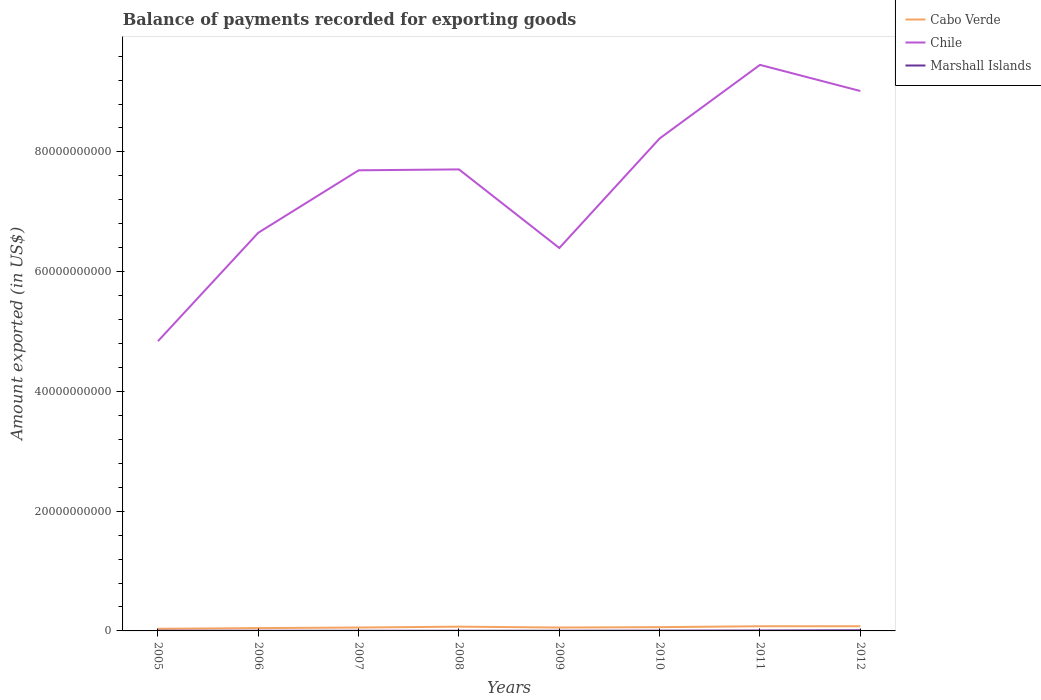How many different coloured lines are there?
Your answer should be very brief. 3. Is the number of lines equal to the number of legend labels?
Make the answer very short. Yes. Across all years, what is the maximum amount exported in Chile?
Keep it short and to the point. 4.84e+1. In which year was the amount exported in Chile maximum?
Make the answer very short. 2005. What is the total amount exported in Chile in the graph?
Offer a very short reply. -1.57e+1. What is the difference between the highest and the second highest amount exported in Marshall Islands?
Your answer should be compact. 8.14e+07. Are the values on the major ticks of Y-axis written in scientific E-notation?
Provide a succinct answer. No. Does the graph contain any zero values?
Offer a very short reply. No. Does the graph contain grids?
Provide a short and direct response. No. Where does the legend appear in the graph?
Ensure brevity in your answer.  Top right. How are the legend labels stacked?
Your answer should be very brief. Vertical. What is the title of the graph?
Make the answer very short. Balance of payments recorded for exporting goods. Does "Low income" appear as one of the legend labels in the graph?
Your answer should be compact. No. What is the label or title of the X-axis?
Ensure brevity in your answer.  Years. What is the label or title of the Y-axis?
Keep it short and to the point. Amount exported (in US$). What is the Amount exported (in US$) in Cabo Verde in 2005?
Offer a terse response. 3.54e+08. What is the Amount exported (in US$) of Chile in 2005?
Your response must be concise. 4.84e+1. What is the Amount exported (in US$) in Marshall Islands in 2005?
Offer a very short reply. 3.33e+07. What is the Amount exported (in US$) in Cabo Verde in 2006?
Provide a short and direct response. 4.72e+08. What is the Amount exported (in US$) of Chile in 2006?
Give a very brief answer. 6.65e+1. What is the Amount exported (in US$) in Marshall Islands in 2006?
Offer a terse response. 2.77e+07. What is the Amount exported (in US$) in Cabo Verde in 2007?
Make the answer very short. 5.66e+08. What is the Amount exported (in US$) of Chile in 2007?
Provide a succinct answer. 7.69e+1. What is the Amount exported (in US$) in Marshall Islands in 2007?
Provide a short and direct response. 2.77e+07. What is the Amount exported (in US$) of Cabo Verde in 2008?
Offer a very short reply. 7.10e+08. What is the Amount exported (in US$) of Chile in 2008?
Provide a succinct answer. 7.71e+1. What is the Amount exported (in US$) of Marshall Islands in 2008?
Make the answer very short. 2.98e+07. What is the Amount exported (in US$) of Cabo Verde in 2009?
Keep it short and to the point. 5.67e+08. What is the Amount exported (in US$) of Chile in 2009?
Your answer should be compact. 6.40e+1. What is the Amount exported (in US$) in Marshall Islands in 2009?
Ensure brevity in your answer.  3.09e+07. What is the Amount exported (in US$) in Cabo Verde in 2010?
Offer a terse response. 6.30e+08. What is the Amount exported (in US$) in Chile in 2010?
Your answer should be compact. 8.23e+1. What is the Amount exported (in US$) of Marshall Islands in 2010?
Your answer should be very brief. 5.00e+07. What is the Amount exported (in US$) in Cabo Verde in 2011?
Provide a succinct answer. 7.82e+08. What is the Amount exported (in US$) in Chile in 2011?
Keep it short and to the point. 9.45e+1. What is the Amount exported (in US$) in Marshall Islands in 2011?
Your answer should be very brief. 7.13e+07. What is the Amount exported (in US$) in Cabo Verde in 2012?
Your answer should be very brief. 7.84e+08. What is the Amount exported (in US$) of Chile in 2012?
Keep it short and to the point. 9.02e+1. What is the Amount exported (in US$) of Marshall Islands in 2012?
Ensure brevity in your answer.  1.09e+08. Across all years, what is the maximum Amount exported (in US$) of Cabo Verde?
Your response must be concise. 7.84e+08. Across all years, what is the maximum Amount exported (in US$) of Chile?
Offer a very short reply. 9.45e+1. Across all years, what is the maximum Amount exported (in US$) of Marshall Islands?
Provide a succinct answer. 1.09e+08. Across all years, what is the minimum Amount exported (in US$) in Cabo Verde?
Keep it short and to the point. 3.54e+08. Across all years, what is the minimum Amount exported (in US$) in Chile?
Your answer should be very brief. 4.84e+1. Across all years, what is the minimum Amount exported (in US$) of Marshall Islands?
Your response must be concise. 2.77e+07. What is the total Amount exported (in US$) of Cabo Verde in the graph?
Provide a short and direct response. 4.87e+09. What is the total Amount exported (in US$) of Chile in the graph?
Your response must be concise. 6.00e+11. What is the total Amount exported (in US$) of Marshall Islands in the graph?
Provide a succinct answer. 3.80e+08. What is the difference between the Amount exported (in US$) in Cabo Verde in 2005 and that in 2006?
Your response must be concise. -1.19e+08. What is the difference between the Amount exported (in US$) in Chile in 2005 and that in 2006?
Ensure brevity in your answer.  -1.81e+1. What is the difference between the Amount exported (in US$) in Marshall Islands in 2005 and that in 2006?
Provide a short and direct response. 5.63e+06. What is the difference between the Amount exported (in US$) of Cabo Verde in 2005 and that in 2007?
Give a very brief answer. -2.12e+08. What is the difference between the Amount exported (in US$) in Chile in 2005 and that in 2007?
Your answer should be very brief. -2.85e+1. What is the difference between the Amount exported (in US$) in Marshall Islands in 2005 and that in 2007?
Keep it short and to the point. 5.56e+06. What is the difference between the Amount exported (in US$) in Cabo Verde in 2005 and that in 2008?
Offer a terse response. -3.57e+08. What is the difference between the Amount exported (in US$) in Chile in 2005 and that in 2008?
Your response must be concise. -2.87e+1. What is the difference between the Amount exported (in US$) of Marshall Islands in 2005 and that in 2008?
Provide a succinct answer. 3.53e+06. What is the difference between the Amount exported (in US$) of Cabo Verde in 2005 and that in 2009?
Ensure brevity in your answer.  -2.14e+08. What is the difference between the Amount exported (in US$) of Chile in 2005 and that in 2009?
Your answer should be compact. -1.56e+1. What is the difference between the Amount exported (in US$) of Marshall Islands in 2005 and that in 2009?
Provide a short and direct response. 2.35e+06. What is the difference between the Amount exported (in US$) in Cabo Verde in 2005 and that in 2010?
Ensure brevity in your answer.  -2.76e+08. What is the difference between the Amount exported (in US$) of Chile in 2005 and that in 2010?
Keep it short and to the point. -3.39e+1. What is the difference between the Amount exported (in US$) of Marshall Islands in 2005 and that in 2010?
Ensure brevity in your answer.  -1.67e+07. What is the difference between the Amount exported (in US$) of Cabo Verde in 2005 and that in 2011?
Offer a terse response. -4.28e+08. What is the difference between the Amount exported (in US$) of Chile in 2005 and that in 2011?
Your answer should be compact. -4.61e+1. What is the difference between the Amount exported (in US$) in Marshall Islands in 2005 and that in 2011?
Ensure brevity in your answer.  -3.80e+07. What is the difference between the Amount exported (in US$) of Cabo Verde in 2005 and that in 2012?
Make the answer very short. -4.30e+08. What is the difference between the Amount exported (in US$) of Chile in 2005 and that in 2012?
Your response must be concise. -4.18e+1. What is the difference between the Amount exported (in US$) in Marshall Islands in 2005 and that in 2012?
Ensure brevity in your answer.  -7.58e+07. What is the difference between the Amount exported (in US$) in Cabo Verde in 2006 and that in 2007?
Your response must be concise. -9.37e+07. What is the difference between the Amount exported (in US$) of Chile in 2006 and that in 2007?
Your answer should be compact. -1.04e+1. What is the difference between the Amount exported (in US$) of Marshall Islands in 2006 and that in 2007?
Provide a succinct answer. -7.31e+04. What is the difference between the Amount exported (in US$) in Cabo Verde in 2006 and that in 2008?
Your answer should be compact. -2.38e+08. What is the difference between the Amount exported (in US$) in Chile in 2006 and that in 2008?
Your response must be concise. -1.06e+1. What is the difference between the Amount exported (in US$) of Marshall Islands in 2006 and that in 2008?
Your answer should be compact. -2.10e+06. What is the difference between the Amount exported (in US$) in Cabo Verde in 2006 and that in 2009?
Make the answer very short. -9.51e+07. What is the difference between the Amount exported (in US$) of Chile in 2006 and that in 2009?
Offer a very short reply. 2.56e+09. What is the difference between the Amount exported (in US$) in Marshall Islands in 2006 and that in 2009?
Keep it short and to the point. -3.28e+06. What is the difference between the Amount exported (in US$) in Cabo Verde in 2006 and that in 2010?
Ensure brevity in your answer.  -1.57e+08. What is the difference between the Amount exported (in US$) of Chile in 2006 and that in 2010?
Ensure brevity in your answer.  -1.57e+1. What is the difference between the Amount exported (in US$) in Marshall Islands in 2006 and that in 2010?
Your answer should be very brief. -2.23e+07. What is the difference between the Amount exported (in US$) of Cabo Verde in 2006 and that in 2011?
Provide a short and direct response. -3.10e+08. What is the difference between the Amount exported (in US$) in Chile in 2006 and that in 2011?
Ensure brevity in your answer.  -2.80e+1. What is the difference between the Amount exported (in US$) in Marshall Islands in 2006 and that in 2011?
Provide a short and direct response. -4.37e+07. What is the difference between the Amount exported (in US$) in Cabo Verde in 2006 and that in 2012?
Keep it short and to the point. -3.12e+08. What is the difference between the Amount exported (in US$) of Chile in 2006 and that in 2012?
Your answer should be very brief. -2.37e+1. What is the difference between the Amount exported (in US$) of Marshall Islands in 2006 and that in 2012?
Make the answer very short. -8.14e+07. What is the difference between the Amount exported (in US$) in Cabo Verde in 2007 and that in 2008?
Provide a succinct answer. -1.44e+08. What is the difference between the Amount exported (in US$) in Chile in 2007 and that in 2008?
Keep it short and to the point. -1.48e+08. What is the difference between the Amount exported (in US$) in Marshall Islands in 2007 and that in 2008?
Your response must be concise. -2.03e+06. What is the difference between the Amount exported (in US$) of Cabo Verde in 2007 and that in 2009?
Keep it short and to the point. -1.34e+06. What is the difference between the Amount exported (in US$) of Chile in 2007 and that in 2009?
Provide a succinct answer. 1.30e+1. What is the difference between the Amount exported (in US$) of Marshall Islands in 2007 and that in 2009?
Make the answer very short. -3.20e+06. What is the difference between the Amount exported (in US$) in Cabo Verde in 2007 and that in 2010?
Ensure brevity in your answer.  -6.37e+07. What is the difference between the Amount exported (in US$) of Chile in 2007 and that in 2010?
Offer a very short reply. -5.32e+09. What is the difference between the Amount exported (in US$) in Marshall Islands in 2007 and that in 2010?
Your answer should be compact. -2.23e+07. What is the difference between the Amount exported (in US$) in Cabo Verde in 2007 and that in 2011?
Your answer should be very brief. -2.16e+08. What is the difference between the Amount exported (in US$) of Chile in 2007 and that in 2011?
Provide a short and direct response. -1.76e+1. What is the difference between the Amount exported (in US$) of Marshall Islands in 2007 and that in 2011?
Keep it short and to the point. -4.36e+07. What is the difference between the Amount exported (in US$) of Cabo Verde in 2007 and that in 2012?
Make the answer very short. -2.18e+08. What is the difference between the Amount exported (in US$) of Chile in 2007 and that in 2012?
Provide a short and direct response. -1.32e+1. What is the difference between the Amount exported (in US$) in Marshall Islands in 2007 and that in 2012?
Your response must be concise. -8.14e+07. What is the difference between the Amount exported (in US$) in Cabo Verde in 2008 and that in 2009?
Your answer should be very brief. 1.43e+08. What is the difference between the Amount exported (in US$) of Chile in 2008 and that in 2009?
Your response must be concise. 1.31e+1. What is the difference between the Amount exported (in US$) of Marshall Islands in 2008 and that in 2009?
Keep it short and to the point. -1.17e+06. What is the difference between the Amount exported (in US$) in Cabo Verde in 2008 and that in 2010?
Offer a terse response. 8.07e+07. What is the difference between the Amount exported (in US$) of Chile in 2008 and that in 2010?
Your answer should be compact. -5.17e+09. What is the difference between the Amount exported (in US$) of Marshall Islands in 2008 and that in 2010?
Provide a short and direct response. -2.02e+07. What is the difference between the Amount exported (in US$) in Cabo Verde in 2008 and that in 2011?
Offer a very short reply. -7.14e+07. What is the difference between the Amount exported (in US$) of Chile in 2008 and that in 2011?
Provide a short and direct response. -1.75e+1. What is the difference between the Amount exported (in US$) in Marshall Islands in 2008 and that in 2011?
Keep it short and to the point. -4.16e+07. What is the difference between the Amount exported (in US$) in Cabo Verde in 2008 and that in 2012?
Offer a very short reply. -7.34e+07. What is the difference between the Amount exported (in US$) of Chile in 2008 and that in 2012?
Offer a very short reply. -1.31e+1. What is the difference between the Amount exported (in US$) in Marshall Islands in 2008 and that in 2012?
Provide a short and direct response. -7.93e+07. What is the difference between the Amount exported (in US$) of Cabo Verde in 2009 and that in 2010?
Your response must be concise. -6.24e+07. What is the difference between the Amount exported (in US$) of Chile in 2009 and that in 2010?
Provide a succinct answer. -1.83e+1. What is the difference between the Amount exported (in US$) of Marshall Islands in 2009 and that in 2010?
Your answer should be very brief. -1.91e+07. What is the difference between the Amount exported (in US$) of Cabo Verde in 2009 and that in 2011?
Make the answer very short. -2.15e+08. What is the difference between the Amount exported (in US$) of Chile in 2009 and that in 2011?
Your response must be concise. -3.06e+1. What is the difference between the Amount exported (in US$) of Marshall Islands in 2009 and that in 2011?
Keep it short and to the point. -4.04e+07. What is the difference between the Amount exported (in US$) in Cabo Verde in 2009 and that in 2012?
Ensure brevity in your answer.  -2.17e+08. What is the difference between the Amount exported (in US$) of Chile in 2009 and that in 2012?
Provide a succinct answer. -2.62e+1. What is the difference between the Amount exported (in US$) of Marshall Islands in 2009 and that in 2012?
Ensure brevity in your answer.  -7.82e+07. What is the difference between the Amount exported (in US$) in Cabo Verde in 2010 and that in 2011?
Give a very brief answer. -1.52e+08. What is the difference between the Amount exported (in US$) in Chile in 2010 and that in 2011?
Make the answer very short. -1.23e+1. What is the difference between the Amount exported (in US$) of Marshall Islands in 2010 and that in 2011?
Offer a very short reply. -2.13e+07. What is the difference between the Amount exported (in US$) in Cabo Verde in 2010 and that in 2012?
Make the answer very short. -1.54e+08. What is the difference between the Amount exported (in US$) of Chile in 2010 and that in 2012?
Make the answer very short. -7.92e+09. What is the difference between the Amount exported (in US$) of Marshall Islands in 2010 and that in 2012?
Provide a short and direct response. -5.91e+07. What is the difference between the Amount exported (in US$) of Cabo Verde in 2011 and that in 2012?
Your response must be concise. -2.00e+06. What is the difference between the Amount exported (in US$) in Chile in 2011 and that in 2012?
Ensure brevity in your answer.  4.37e+09. What is the difference between the Amount exported (in US$) in Marshall Islands in 2011 and that in 2012?
Make the answer very short. -3.78e+07. What is the difference between the Amount exported (in US$) in Cabo Verde in 2005 and the Amount exported (in US$) in Chile in 2006?
Provide a short and direct response. -6.62e+1. What is the difference between the Amount exported (in US$) in Cabo Verde in 2005 and the Amount exported (in US$) in Marshall Islands in 2006?
Offer a very short reply. 3.26e+08. What is the difference between the Amount exported (in US$) of Chile in 2005 and the Amount exported (in US$) of Marshall Islands in 2006?
Your response must be concise. 4.84e+1. What is the difference between the Amount exported (in US$) of Cabo Verde in 2005 and the Amount exported (in US$) of Chile in 2007?
Ensure brevity in your answer.  -7.66e+1. What is the difference between the Amount exported (in US$) of Cabo Verde in 2005 and the Amount exported (in US$) of Marshall Islands in 2007?
Provide a succinct answer. 3.26e+08. What is the difference between the Amount exported (in US$) of Chile in 2005 and the Amount exported (in US$) of Marshall Islands in 2007?
Keep it short and to the point. 4.84e+1. What is the difference between the Amount exported (in US$) of Cabo Verde in 2005 and the Amount exported (in US$) of Chile in 2008?
Keep it short and to the point. -7.67e+1. What is the difference between the Amount exported (in US$) of Cabo Verde in 2005 and the Amount exported (in US$) of Marshall Islands in 2008?
Provide a succinct answer. 3.24e+08. What is the difference between the Amount exported (in US$) of Chile in 2005 and the Amount exported (in US$) of Marshall Islands in 2008?
Ensure brevity in your answer.  4.84e+1. What is the difference between the Amount exported (in US$) in Cabo Verde in 2005 and the Amount exported (in US$) in Chile in 2009?
Give a very brief answer. -6.36e+1. What is the difference between the Amount exported (in US$) in Cabo Verde in 2005 and the Amount exported (in US$) in Marshall Islands in 2009?
Provide a succinct answer. 3.23e+08. What is the difference between the Amount exported (in US$) in Chile in 2005 and the Amount exported (in US$) in Marshall Islands in 2009?
Give a very brief answer. 4.84e+1. What is the difference between the Amount exported (in US$) of Cabo Verde in 2005 and the Amount exported (in US$) of Chile in 2010?
Keep it short and to the point. -8.19e+1. What is the difference between the Amount exported (in US$) of Cabo Verde in 2005 and the Amount exported (in US$) of Marshall Islands in 2010?
Offer a terse response. 3.04e+08. What is the difference between the Amount exported (in US$) in Chile in 2005 and the Amount exported (in US$) in Marshall Islands in 2010?
Offer a very short reply. 4.84e+1. What is the difference between the Amount exported (in US$) of Cabo Verde in 2005 and the Amount exported (in US$) of Chile in 2011?
Provide a short and direct response. -9.42e+1. What is the difference between the Amount exported (in US$) of Cabo Verde in 2005 and the Amount exported (in US$) of Marshall Islands in 2011?
Keep it short and to the point. 2.82e+08. What is the difference between the Amount exported (in US$) of Chile in 2005 and the Amount exported (in US$) of Marshall Islands in 2011?
Your answer should be compact. 4.83e+1. What is the difference between the Amount exported (in US$) in Cabo Verde in 2005 and the Amount exported (in US$) in Chile in 2012?
Ensure brevity in your answer.  -8.98e+1. What is the difference between the Amount exported (in US$) in Cabo Verde in 2005 and the Amount exported (in US$) in Marshall Islands in 2012?
Your answer should be very brief. 2.45e+08. What is the difference between the Amount exported (in US$) of Chile in 2005 and the Amount exported (in US$) of Marshall Islands in 2012?
Ensure brevity in your answer.  4.83e+1. What is the difference between the Amount exported (in US$) of Cabo Verde in 2006 and the Amount exported (in US$) of Chile in 2007?
Ensure brevity in your answer.  -7.65e+1. What is the difference between the Amount exported (in US$) of Cabo Verde in 2006 and the Amount exported (in US$) of Marshall Islands in 2007?
Provide a short and direct response. 4.45e+08. What is the difference between the Amount exported (in US$) of Chile in 2006 and the Amount exported (in US$) of Marshall Islands in 2007?
Your answer should be very brief. 6.65e+1. What is the difference between the Amount exported (in US$) of Cabo Verde in 2006 and the Amount exported (in US$) of Chile in 2008?
Offer a terse response. -7.66e+1. What is the difference between the Amount exported (in US$) in Cabo Verde in 2006 and the Amount exported (in US$) in Marshall Islands in 2008?
Make the answer very short. 4.43e+08. What is the difference between the Amount exported (in US$) of Chile in 2006 and the Amount exported (in US$) of Marshall Islands in 2008?
Provide a short and direct response. 6.65e+1. What is the difference between the Amount exported (in US$) in Cabo Verde in 2006 and the Amount exported (in US$) in Chile in 2009?
Ensure brevity in your answer.  -6.35e+1. What is the difference between the Amount exported (in US$) in Cabo Verde in 2006 and the Amount exported (in US$) in Marshall Islands in 2009?
Provide a short and direct response. 4.41e+08. What is the difference between the Amount exported (in US$) of Chile in 2006 and the Amount exported (in US$) of Marshall Islands in 2009?
Ensure brevity in your answer.  6.65e+1. What is the difference between the Amount exported (in US$) in Cabo Verde in 2006 and the Amount exported (in US$) in Chile in 2010?
Provide a short and direct response. -8.18e+1. What is the difference between the Amount exported (in US$) of Cabo Verde in 2006 and the Amount exported (in US$) of Marshall Islands in 2010?
Keep it short and to the point. 4.22e+08. What is the difference between the Amount exported (in US$) in Chile in 2006 and the Amount exported (in US$) in Marshall Islands in 2010?
Offer a terse response. 6.65e+1. What is the difference between the Amount exported (in US$) of Cabo Verde in 2006 and the Amount exported (in US$) of Chile in 2011?
Offer a very short reply. -9.41e+1. What is the difference between the Amount exported (in US$) of Cabo Verde in 2006 and the Amount exported (in US$) of Marshall Islands in 2011?
Provide a succinct answer. 4.01e+08. What is the difference between the Amount exported (in US$) of Chile in 2006 and the Amount exported (in US$) of Marshall Islands in 2011?
Your answer should be very brief. 6.64e+1. What is the difference between the Amount exported (in US$) in Cabo Verde in 2006 and the Amount exported (in US$) in Chile in 2012?
Provide a short and direct response. -8.97e+1. What is the difference between the Amount exported (in US$) of Cabo Verde in 2006 and the Amount exported (in US$) of Marshall Islands in 2012?
Provide a succinct answer. 3.63e+08. What is the difference between the Amount exported (in US$) of Chile in 2006 and the Amount exported (in US$) of Marshall Islands in 2012?
Offer a terse response. 6.64e+1. What is the difference between the Amount exported (in US$) of Cabo Verde in 2007 and the Amount exported (in US$) of Chile in 2008?
Offer a terse response. -7.65e+1. What is the difference between the Amount exported (in US$) in Cabo Verde in 2007 and the Amount exported (in US$) in Marshall Islands in 2008?
Offer a very short reply. 5.36e+08. What is the difference between the Amount exported (in US$) in Chile in 2007 and the Amount exported (in US$) in Marshall Islands in 2008?
Give a very brief answer. 7.69e+1. What is the difference between the Amount exported (in US$) in Cabo Verde in 2007 and the Amount exported (in US$) in Chile in 2009?
Make the answer very short. -6.34e+1. What is the difference between the Amount exported (in US$) of Cabo Verde in 2007 and the Amount exported (in US$) of Marshall Islands in 2009?
Give a very brief answer. 5.35e+08. What is the difference between the Amount exported (in US$) of Chile in 2007 and the Amount exported (in US$) of Marshall Islands in 2009?
Offer a very short reply. 7.69e+1. What is the difference between the Amount exported (in US$) in Cabo Verde in 2007 and the Amount exported (in US$) in Chile in 2010?
Keep it short and to the point. -8.17e+1. What is the difference between the Amount exported (in US$) of Cabo Verde in 2007 and the Amount exported (in US$) of Marshall Islands in 2010?
Ensure brevity in your answer.  5.16e+08. What is the difference between the Amount exported (in US$) in Chile in 2007 and the Amount exported (in US$) in Marshall Islands in 2010?
Your answer should be very brief. 7.69e+1. What is the difference between the Amount exported (in US$) of Cabo Verde in 2007 and the Amount exported (in US$) of Chile in 2011?
Provide a short and direct response. -9.40e+1. What is the difference between the Amount exported (in US$) in Cabo Verde in 2007 and the Amount exported (in US$) in Marshall Islands in 2011?
Your answer should be compact. 4.95e+08. What is the difference between the Amount exported (in US$) of Chile in 2007 and the Amount exported (in US$) of Marshall Islands in 2011?
Your answer should be very brief. 7.69e+1. What is the difference between the Amount exported (in US$) in Cabo Verde in 2007 and the Amount exported (in US$) in Chile in 2012?
Provide a succinct answer. -8.96e+1. What is the difference between the Amount exported (in US$) of Cabo Verde in 2007 and the Amount exported (in US$) of Marshall Islands in 2012?
Your response must be concise. 4.57e+08. What is the difference between the Amount exported (in US$) of Chile in 2007 and the Amount exported (in US$) of Marshall Islands in 2012?
Provide a short and direct response. 7.68e+1. What is the difference between the Amount exported (in US$) in Cabo Verde in 2008 and the Amount exported (in US$) in Chile in 2009?
Offer a terse response. -6.32e+1. What is the difference between the Amount exported (in US$) of Cabo Verde in 2008 and the Amount exported (in US$) of Marshall Islands in 2009?
Make the answer very short. 6.80e+08. What is the difference between the Amount exported (in US$) in Chile in 2008 and the Amount exported (in US$) in Marshall Islands in 2009?
Your answer should be very brief. 7.71e+1. What is the difference between the Amount exported (in US$) in Cabo Verde in 2008 and the Amount exported (in US$) in Chile in 2010?
Give a very brief answer. -8.15e+1. What is the difference between the Amount exported (in US$) in Cabo Verde in 2008 and the Amount exported (in US$) in Marshall Islands in 2010?
Provide a short and direct response. 6.61e+08. What is the difference between the Amount exported (in US$) in Chile in 2008 and the Amount exported (in US$) in Marshall Islands in 2010?
Provide a short and direct response. 7.70e+1. What is the difference between the Amount exported (in US$) in Cabo Verde in 2008 and the Amount exported (in US$) in Chile in 2011?
Make the answer very short. -9.38e+1. What is the difference between the Amount exported (in US$) of Cabo Verde in 2008 and the Amount exported (in US$) of Marshall Islands in 2011?
Offer a very short reply. 6.39e+08. What is the difference between the Amount exported (in US$) in Chile in 2008 and the Amount exported (in US$) in Marshall Islands in 2011?
Ensure brevity in your answer.  7.70e+1. What is the difference between the Amount exported (in US$) in Cabo Verde in 2008 and the Amount exported (in US$) in Chile in 2012?
Ensure brevity in your answer.  -8.95e+1. What is the difference between the Amount exported (in US$) in Cabo Verde in 2008 and the Amount exported (in US$) in Marshall Islands in 2012?
Offer a very short reply. 6.01e+08. What is the difference between the Amount exported (in US$) in Chile in 2008 and the Amount exported (in US$) in Marshall Islands in 2012?
Provide a succinct answer. 7.70e+1. What is the difference between the Amount exported (in US$) of Cabo Verde in 2009 and the Amount exported (in US$) of Chile in 2010?
Provide a succinct answer. -8.17e+1. What is the difference between the Amount exported (in US$) of Cabo Verde in 2009 and the Amount exported (in US$) of Marshall Islands in 2010?
Give a very brief answer. 5.17e+08. What is the difference between the Amount exported (in US$) in Chile in 2009 and the Amount exported (in US$) in Marshall Islands in 2010?
Offer a very short reply. 6.39e+1. What is the difference between the Amount exported (in US$) of Cabo Verde in 2009 and the Amount exported (in US$) of Chile in 2011?
Provide a succinct answer. -9.40e+1. What is the difference between the Amount exported (in US$) of Cabo Verde in 2009 and the Amount exported (in US$) of Marshall Islands in 2011?
Offer a very short reply. 4.96e+08. What is the difference between the Amount exported (in US$) of Chile in 2009 and the Amount exported (in US$) of Marshall Islands in 2011?
Give a very brief answer. 6.39e+1. What is the difference between the Amount exported (in US$) in Cabo Verde in 2009 and the Amount exported (in US$) in Chile in 2012?
Keep it short and to the point. -8.96e+1. What is the difference between the Amount exported (in US$) in Cabo Verde in 2009 and the Amount exported (in US$) in Marshall Islands in 2012?
Your answer should be compact. 4.58e+08. What is the difference between the Amount exported (in US$) in Chile in 2009 and the Amount exported (in US$) in Marshall Islands in 2012?
Your answer should be compact. 6.38e+1. What is the difference between the Amount exported (in US$) of Cabo Verde in 2010 and the Amount exported (in US$) of Chile in 2011?
Give a very brief answer. -9.39e+1. What is the difference between the Amount exported (in US$) in Cabo Verde in 2010 and the Amount exported (in US$) in Marshall Islands in 2011?
Offer a very short reply. 5.58e+08. What is the difference between the Amount exported (in US$) in Chile in 2010 and the Amount exported (in US$) in Marshall Islands in 2011?
Provide a succinct answer. 8.22e+1. What is the difference between the Amount exported (in US$) of Cabo Verde in 2010 and the Amount exported (in US$) of Chile in 2012?
Offer a very short reply. -8.95e+1. What is the difference between the Amount exported (in US$) in Cabo Verde in 2010 and the Amount exported (in US$) in Marshall Islands in 2012?
Your answer should be compact. 5.21e+08. What is the difference between the Amount exported (in US$) in Chile in 2010 and the Amount exported (in US$) in Marshall Islands in 2012?
Keep it short and to the point. 8.21e+1. What is the difference between the Amount exported (in US$) in Cabo Verde in 2011 and the Amount exported (in US$) in Chile in 2012?
Ensure brevity in your answer.  -8.94e+1. What is the difference between the Amount exported (in US$) of Cabo Verde in 2011 and the Amount exported (in US$) of Marshall Islands in 2012?
Keep it short and to the point. 6.73e+08. What is the difference between the Amount exported (in US$) of Chile in 2011 and the Amount exported (in US$) of Marshall Islands in 2012?
Provide a succinct answer. 9.44e+1. What is the average Amount exported (in US$) of Cabo Verde per year?
Keep it short and to the point. 6.08e+08. What is the average Amount exported (in US$) in Chile per year?
Make the answer very short. 7.50e+1. What is the average Amount exported (in US$) in Marshall Islands per year?
Keep it short and to the point. 4.75e+07. In the year 2005, what is the difference between the Amount exported (in US$) of Cabo Verde and Amount exported (in US$) of Chile?
Provide a succinct answer. -4.80e+1. In the year 2005, what is the difference between the Amount exported (in US$) in Cabo Verde and Amount exported (in US$) in Marshall Islands?
Make the answer very short. 3.20e+08. In the year 2005, what is the difference between the Amount exported (in US$) of Chile and Amount exported (in US$) of Marshall Islands?
Make the answer very short. 4.84e+1. In the year 2006, what is the difference between the Amount exported (in US$) in Cabo Verde and Amount exported (in US$) in Chile?
Keep it short and to the point. -6.60e+1. In the year 2006, what is the difference between the Amount exported (in US$) in Cabo Verde and Amount exported (in US$) in Marshall Islands?
Your response must be concise. 4.45e+08. In the year 2006, what is the difference between the Amount exported (in US$) of Chile and Amount exported (in US$) of Marshall Islands?
Provide a succinct answer. 6.65e+1. In the year 2007, what is the difference between the Amount exported (in US$) of Cabo Verde and Amount exported (in US$) of Chile?
Offer a terse response. -7.64e+1. In the year 2007, what is the difference between the Amount exported (in US$) in Cabo Verde and Amount exported (in US$) in Marshall Islands?
Keep it short and to the point. 5.38e+08. In the year 2007, what is the difference between the Amount exported (in US$) of Chile and Amount exported (in US$) of Marshall Islands?
Offer a very short reply. 7.69e+1. In the year 2008, what is the difference between the Amount exported (in US$) of Cabo Verde and Amount exported (in US$) of Chile?
Keep it short and to the point. -7.64e+1. In the year 2008, what is the difference between the Amount exported (in US$) in Cabo Verde and Amount exported (in US$) in Marshall Islands?
Ensure brevity in your answer.  6.81e+08. In the year 2008, what is the difference between the Amount exported (in US$) in Chile and Amount exported (in US$) in Marshall Islands?
Offer a terse response. 7.71e+1. In the year 2009, what is the difference between the Amount exported (in US$) in Cabo Verde and Amount exported (in US$) in Chile?
Offer a terse response. -6.34e+1. In the year 2009, what is the difference between the Amount exported (in US$) in Cabo Verde and Amount exported (in US$) in Marshall Islands?
Your answer should be very brief. 5.36e+08. In the year 2009, what is the difference between the Amount exported (in US$) of Chile and Amount exported (in US$) of Marshall Islands?
Your answer should be compact. 6.39e+1. In the year 2010, what is the difference between the Amount exported (in US$) in Cabo Verde and Amount exported (in US$) in Chile?
Ensure brevity in your answer.  -8.16e+1. In the year 2010, what is the difference between the Amount exported (in US$) in Cabo Verde and Amount exported (in US$) in Marshall Islands?
Keep it short and to the point. 5.80e+08. In the year 2010, what is the difference between the Amount exported (in US$) of Chile and Amount exported (in US$) of Marshall Islands?
Provide a short and direct response. 8.22e+1. In the year 2011, what is the difference between the Amount exported (in US$) in Cabo Verde and Amount exported (in US$) in Chile?
Keep it short and to the point. -9.38e+1. In the year 2011, what is the difference between the Amount exported (in US$) in Cabo Verde and Amount exported (in US$) in Marshall Islands?
Ensure brevity in your answer.  7.11e+08. In the year 2011, what is the difference between the Amount exported (in US$) of Chile and Amount exported (in US$) of Marshall Islands?
Offer a terse response. 9.45e+1. In the year 2012, what is the difference between the Amount exported (in US$) in Cabo Verde and Amount exported (in US$) in Chile?
Offer a very short reply. -8.94e+1. In the year 2012, what is the difference between the Amount exported (in US$) of Cabo Verde and Amount exported (in US$) of Marshall Islands?
Provide a succinct answer. 6.75e+08. In the year 2012, what is the difference between the Amount exported (in US$) in Chile and Amount exported (in US$) in Marshall Islands?
Your answer should be very brief. 9.01e+1. What is the ratio of the Amount exported (in US$) of Cabo Verde in 2005 to that in 2006?
Your answer should be compact. 0.75. What is the ratio of the Amount exported (in US$) of Chile in 2005 to that in 2006?
Keep it short and to the point. 0.73. What is the ratio of the Amount exported (in US$) of Marshall Islands in 2005 to that in 2006?
Provide a short and direct response. 1.2. What is the ratio of the Amount exported (in US$) of Cabo Verde in 2005 to that in 2007?
Offer a terse response. 0.62. What is the ratio of the Amount exported (in US$) in Chile in 2005 to that in 2007?
Keep it short and to the point. 0.63. What is the ratio of the Amount exported (in US$) in Marshall Islands in 2005 to that in 2007?
Provide a succinct answer. 1.2. What is the ratio of the Amount exported (in US$) of Cabo Verde in 2005 to that in 2008?
Provide a short and direct response. 0.5. What is the ratio of the Amount exported (in US$) of Chile in 2005 to that in 2008?
Your response must be concise. 0.63. What is the ratio of the Amount exported (in US$) in Marshall Islands in 2005 to that in 2008?
Make the answer very short. 1.12. What is the ratio of the Amount exported (in US$) in Cabo Verde in 2005 to that in 2009?
Provide a succinct answer. 0.62. What is the ratio of the Amount exported (in US$) in Chile in 2005 to that in 2009?
Provide a succinct answer. 0.76. What is the ratio of the Amount exported (in US$) of Marshall Islands in 2005 to that in 2009?
Make the answer very short. 1.08. What is the ratio of the Amount exported (in US$) in Cabo Verde in 2005 to that in 2010?
Your answer should be very brief. 0.56. What is the ratio of the Amount exported (in US$) in Chile in 2005 to that in 2010?
Ensure brevity in your answer.  0.59. What is the ratio of the Amount exported (in US$) in Marshall Islands in 2005 to that in 2010?
Provide a succinct answer. 0.67. What is the ratio of the Amount exported (in US$) in Cabo Verde in 2005 to that in 2011?
Offer a terse response. 0.45. What is the ratio of the Amount exported (in US$) in Chile in 2005 to that in 2011?
Make the answer very short. 0.51. What is the ratio of the Amount exported (in US$) in Marshall Islands in 2005 to that in 2011?
Provide a short and direct response. 0.47. What is the ratio of the Amount exported (in US$) of Cabo Verde in 2005 to that in 2012?
Your answer should be compact. 0.45. What is the ratio of the Amount exported (in US$) of Chile in 2005 to that in 2012?
Your answer should be very brief. 0.54. What is the ratio of the Amount exported (in US$) in Marshall Islands in 2005 to that in 2012?
Give a very brief answer. 0.31. What is the ratio of the Amount exported (in US$) in Cabo Verde in 2006 to that in 2007?
Offer a very short reply. 0.83. What is the ratio of the Amount exported (in US$) in Chile in 2006 to that in 2007?
Your response must be concise. 0.86. What is the ratio of the Amount exported (in US$) of Cabo Verde in 2006 to that in 2008?
Offer a terse response. 0.66. What is the ratio of the Amount exported (in US$) in Chile in 2006 to that in 2008?
Offer a terse response. 0.86. What is the ratio of the Amount exported (in US$) of Marshall Islands in 2006 to that in 2008?
Your answer should be compact. 0.93. What is the ratio of the Amount exported (in US$) in Cabo Verde in 2006 to that in 2009?
Offer a very short reply. 0.83. What is the ratio of the Amount exported (in US$) of Chile in 2006 to that in 2009?
Your answer should be very brief. 1.04. What is the ratio of the Amount exported (in US$) in Marshall Islands in 2006 to that in 2009?
Give a very brief answer. 0.89. What is the ratio of the Amount exported (in US$) in Cabo Verde in 2006 to that in 2010?
Your response must be concise. 0.75. What is the ratio of the Amount exported (in US$) in Chile in 2006 to that in 2010?
Offer a very short reply. 0.81. What is the ratio of the Amount exported (in US$) of Marshall Islands in 2006 to that in 2010?
Provide a short and direct response. 0.55. What is the ratio of the Amount exported (in US$) in Cabo Verde in 2006 to that in 2011?
Ensure brevity in your answer.  0.6. What is the ratio of the Amount exported (in US$) in Chile in 2006 to that in 2011?
Offer a very short reply. 0.7. What is the ratio of the Amount exported (in US$) in Marshall Islands in 2006 to that in 2011?
Give a very brief answer. 0.39. What is the ratio of the Amount exported (in US$) in Cabo Verde in 2006 to that in 2012?
Make the answer very short. 0.6. What is the ratio of the Amount exported (in US$) in Chile in 2006 to that in 2012?
Ensure brevity in your answer.  0.74. What is the ratio of the Amount exported (in US$) in Marshall Islands in 2006 to that in 2012?
Keep it short and to the point. 0.25. What is the ratio of the Amount exported (in US$) of Cabo Verde in 2007 to that in 2008?
Ensure brevity in your answer.  0.8. What is the ratio of the Amount exported (in US$) in Marshall Islands in 2007 to that in 2008?
Offer a very short reply. 0.93. What is the ratio of the Amount exported (in US$) of Cabo Verde in 2007 to that in 2009?
Provide a short and direct response. 1. What is the ratio of the Amount exported (in US$) of Chile in 2007 to that in 2009?
Keep it short and to the point. 1.2. What is the ratio of the Amount exported (in US$) of Marshall Islands in 2007 to that in 2009?
Your response must be concise. 0.9. What is the ratio of the Amount exported (in US$) of Cabo Verde in 2007 to that in 2010?
Provide a succinct answer. 0.9. What is the ratio of the Amount exported (in US$) of Chile in 2007 to that in 2010?
Your answer should be very brief. 0.94. What is the ratio of the Amount exported (in US$) in Marshall Islands in 2007 to that in 2010?
Ensure brevity in your answer.  0.55. What is the ratio of the Amount exported (in US$) of Cabo Verde in 2007 to that in 2011?
Make the answer very short. 0.72. What is the ratio of the Amount exported (in US$) in Chile in 2007 to that in 2011?
Provide a short and direct response. 0.81. What is the ratio of the Amount exported (in US$) of Marshall Islands in 2007 to that in 2011?
Make the answer very short. 0.39. What is the ratio of the Amount exported (in US$) of Cabo Verde in 2007 to that in 2012?
Your answer should be very brief. 0.72. What is the ratio of the Amount exported (in US$) of Chile in 2007 to that in 2012?
Ensure brevity in your answer.  0.85. What is the ratio of the Amount exported (in US$) of Marshall Islands in 2007 to that in 2012?
Keep it short and to the point. 0.25. What is the ratio of the Amount exported (in US$) in Cabo Verde in 2008 to that in 2009?
Offer a very short reply. 1.25. What is the ratio of the Amount exported (in US$) of Chile in 2008 to that in 2009?
Keep it short and to the point. 1.21. What is the ratio of the Amount exported (in US$) in Marshall Islands in 2008 to that in 2009?
Provide a short and direct response. 0.96. What is the ratio of the Amount exported (in US$) of Cabo Verde in 2008 to that in 2010?
Ensure brevity in your answer.  1.13. What is the ratio of the Amount exported (in US$) of Chile in 2008 to that in 2010?
Keep it short and to the point. 0.94. What is the ratio of the Amount exported (in US$) of Marshall Islands in 2008 to that in 2010?
Keep it short and to the point. 0.6. What is the ratio of the Amount exported (in US$) of Cabo Verde in 2008 to that in 2011?
Your response must be concise. 0.91. What is the ratio of the Amount exported (in US$) of Chile in 2008 to that in 2011?
Your response must be concise. 0.82. What is the ratio of the Amount exported (in US$) in Marshall Islands in 2008 to that in 2011?
Your answer should be compact. 0.42. What is the ratio of the Amount exported (in US$) of Cabo Verde in 2008 to that in 2012?
Offer a very short reply. 0.91. What is the ratio of the Amount exported (in US$) in Chile in 2008 to that in 2012?
Ensure brevity in your answer.  0.85. What is the ratio of the Amount exported (in US$) in Marshall Islands in 2008 to that in 2012?
Offer a terse response. 0.27. What is the ratio of the Amount exported (in US$) of Cabo Verde in 2009 to that in 2010?
Make the answer very short. 0.9. What is the ratio of the Amount exported (in US$) in Chile in 2009 to that in 2010?
Keep it short and to the point. 0.78. What is the ratio of the Amount exported (in US$) in Marshall Islands in 2009 to that in 2010?
Provide a short and direct response. 0.62. What is the ratio of the Amount exported (in US$) of Cabo Verde in 2009 to that in 2011?
Give a very brief answer. 0.73. What is the ratio of the Amount exported (in US$) of Chile in 2009 to that in 2011?
Offer a terse response. 0.68. What is the ratio of the Amount exported (in US$) of Marshall Islands in 2009 to that in 2011?
Ensure brevity in your answer.  0.43. What is the ratio of the Amount exported (in US$) of Cabo Verde in 2009 to that in 2012?
Offer a very short reply. 0.72. What is the ratio of the Amount exported (in US$) of Chile in 2009 to that in 2012?
Offer a very short reply. 0.71. What is the ratio of the Amount exported (in US$) of Marshall Islands in 2009 to that in 2012?
Make the answer very short. 0.28. What is the ratio of the Amount exported (in US$) of Cabo Verde in 2010 to that in 2011?
Ensure brevity in your answer.  0.81. What is the ratio of the Amount exported (in US$) in Chile in 2010 to that in 2011?
Keep it short and to the point. 0.87. What is the ratio of the Amount exported (in US$) of Marshall Islands in 2010 to that in 2011?
Your response must be concise. 0.7. What is the ratio of the Amount exported (in US$) of Cabo Verde in 2010 to that in 2012?
Your response must be concise. 0.8. What is the ratio of the Amount exported (in US$) in Chile in 2010 to that in 2012?
Your answer should be compact. 0.91. What is the ratio of the Amount exported (in US$) in Marshall Islands in 2010 to that in 2012?
Make the answer very short. 0.46. What is the ratio of the Amount exported (in US$) in Chile in 2011 to that in 2012?
Provide a short and direct response. 1.05. What is the ratio of the Amount exported (in US$) in Marshall Islands in 2011 to that in 2012?
Keep it short and to the point. 0.65. What is the difference between the highest and the second highest Amount exported (in US$) in Cabo Verde?
Provide a succinct answer. 2.00e+06. What is the difference between the highest and the second highest Amount exported (in US$) of Chile?
Keep it short and to the point. 4.37e+09. What is the difference between the highest and the second highest Amount exported (in US$) of Marshall Islands?
Your response must be concise. 3.78e+07. What is the difference between the highest and the lowest Amount exported (in US$) of Cabo Verde?
Give a very brief answer. 4.30e+08. What is the difference between the highest and the lowest Amount exported (in US$) in Chile?
Your answer should be very brief. 4.61e+1. What is the difference between the highest and the lowest Amount exported (in US$) in Marshall Islands?
Your answer should be very brief. 8.14e+07. 